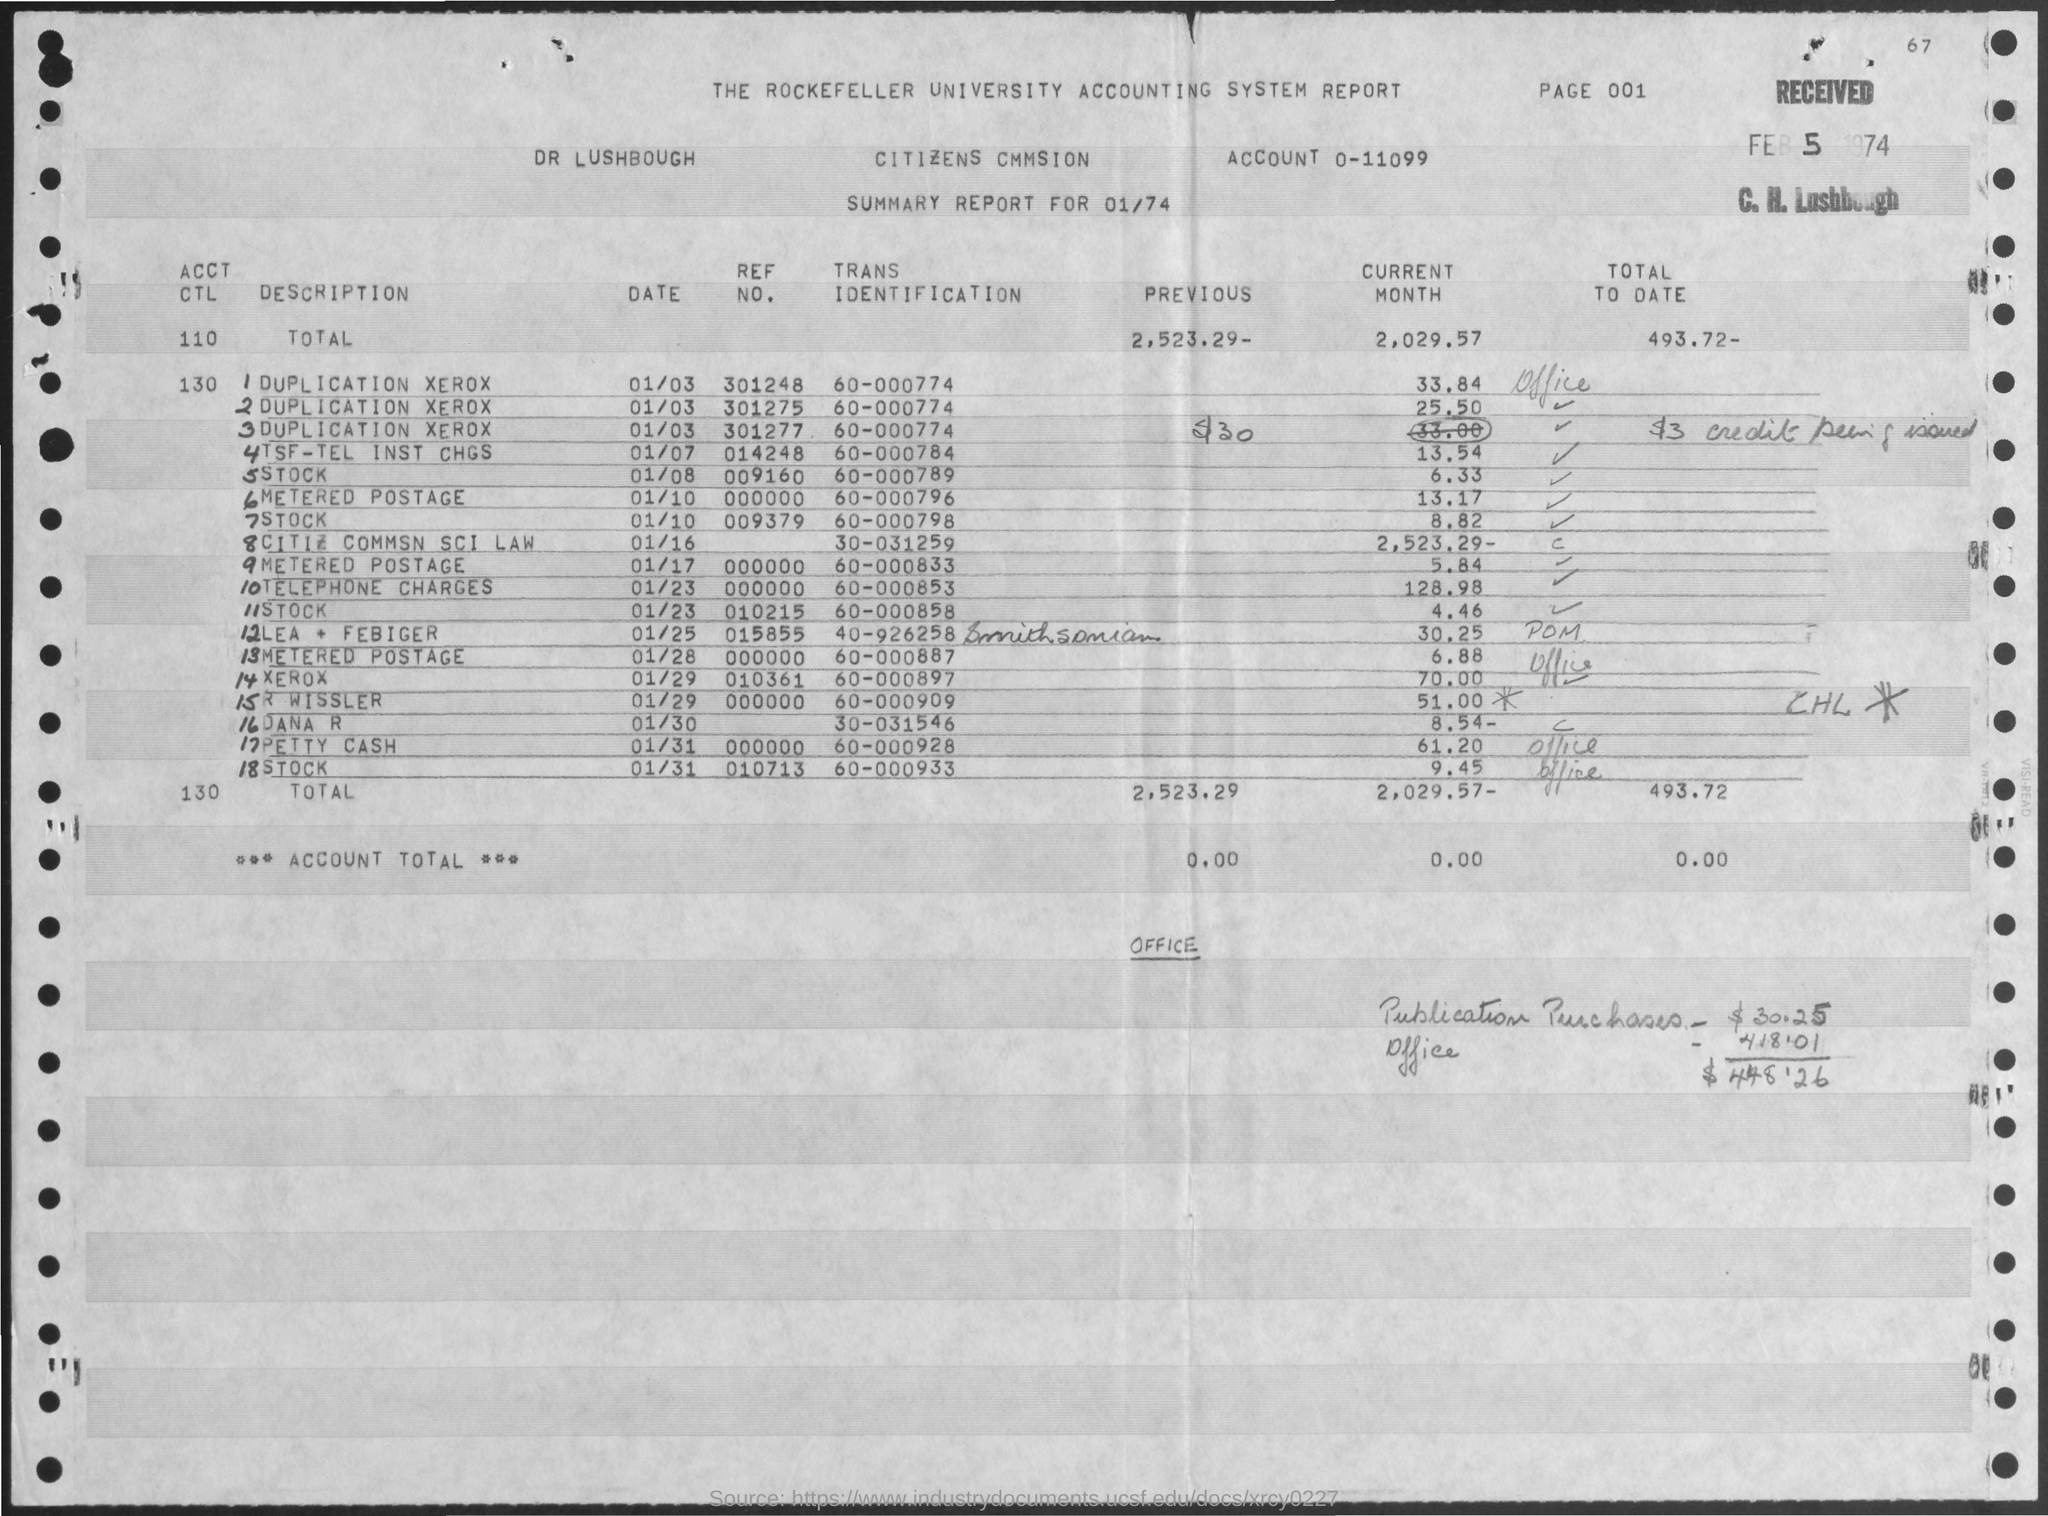What is the date mentioned for summary report ?
Offer a very short reply. 01/74. What is the account no mentioned in the given report ?
Provide a short and direct response. 0-11099. What is the trans identification number for telephone charges as mentioned in the given report ?
Offer a terse response. 60-000853. What is the ref. no. for xerox as mentioned in the given report ?
Offer a terse response. 010361. What is the total amount of the previous as mentioned in the given report ?
Make the answer very short. 2,523.29-. What is the total value of the current month as shown in the report ?
Provide a succinct answer. 2,029.57. What is the total amount of to date as mentioned in the given report ?
Make the answer very short. 493.72-. 